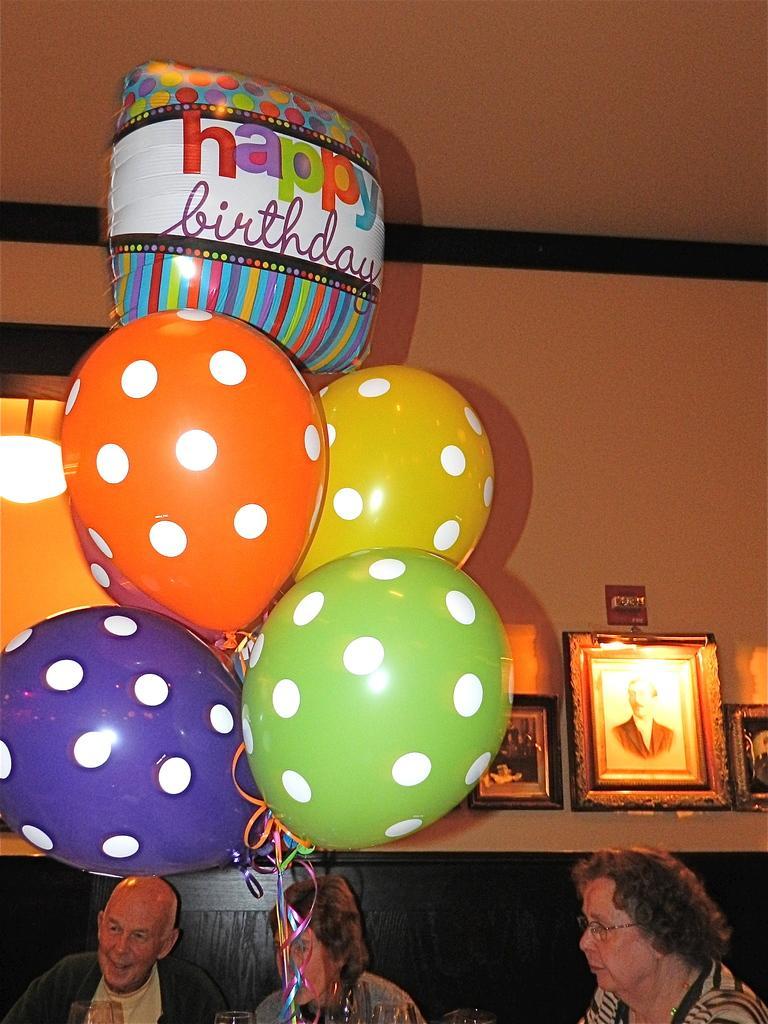Could you give a brief overview of what you see in this image? This image consists of three persons sitting in a room. In the front, we can see the balloons in different colors. In the background, there is a wall on which there are three frames hanged. 